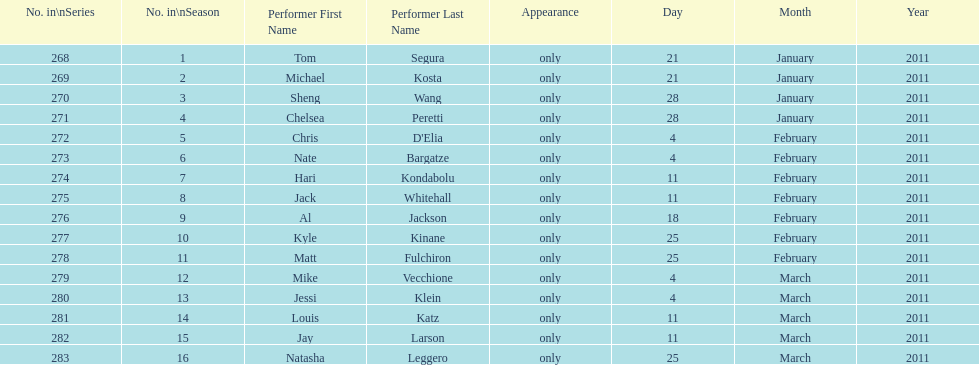Who appeared first tom segura or jay larson? Tom Segura. 